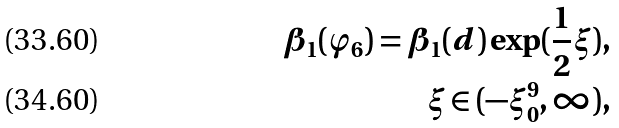<formula> <loc_0><loc_0><loc_500><loc_500>\beta _ { 1 } ( \varphi _ { 6 } ) = \beta _ { 1 } ( d ) \exp ( \frac { 1 } { 2 } \xi ) , \\ \quad \xi \in ( - \xi _ { 0 } ^ { 9 } , \infty ) ,</formula> 